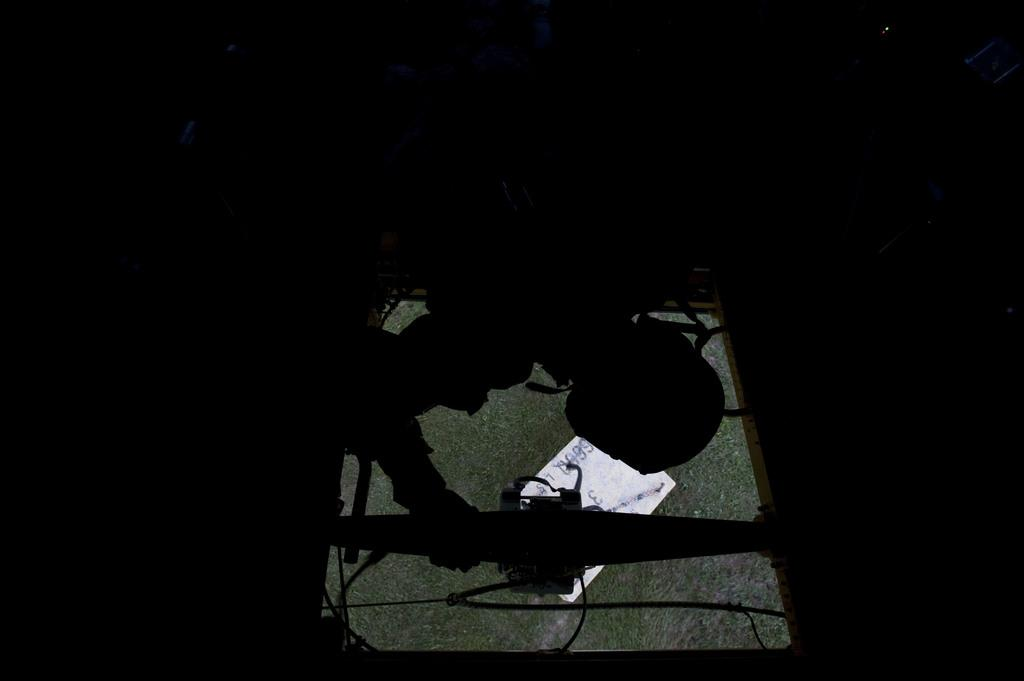What is the main subject of the image? There is a person in the image. What is the person holding in the image? The person is holding a window. What type of surface can be seen behind the window? There is grass on the ground behind the window. Can you describe the color of any objects in the image? There is an object that is white in color in the image. How many beetles can be seen crawling on the person's finger in the image? There are no beetles present in the image, and the person's finger is not visible. What degree does the person have, as shown in the image? There is no indication of a degree in the image, as it does not show any educational or professional qualifications. 